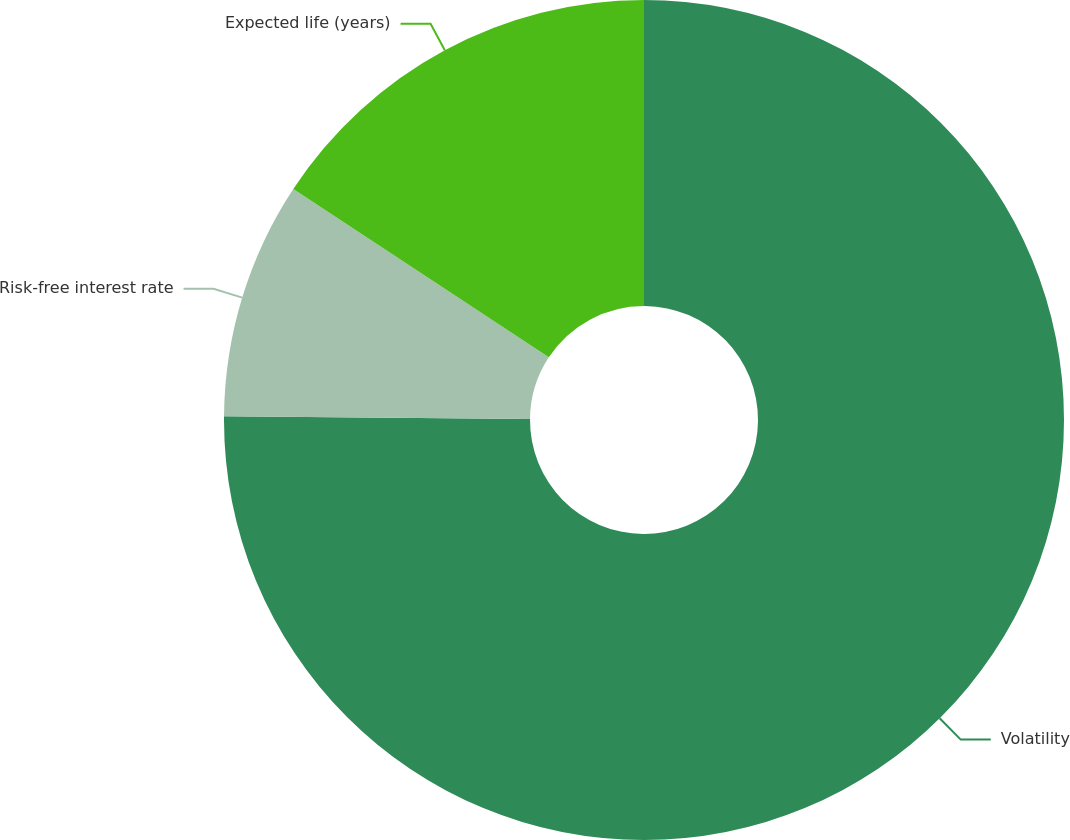Convert chart. <chart><loc_0><loc_0><loc_500><loc_500><pie_chart><fcel>Volatility<fcel>Risk-free interest rate<fcel>Expected life (years)<nl><fcel>75.15%<fcel>9.13%<fcel>15.73%<nl></chart> 